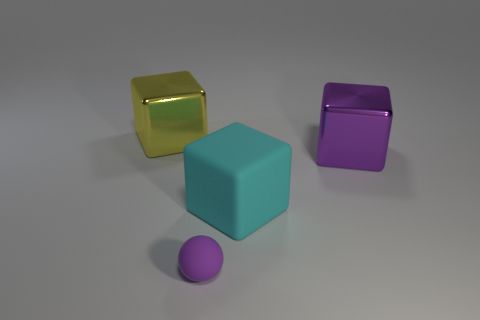The tiny matte ball has what color?
Your response must be concise. Purple. Are there more tiny purple matte things behind the large rubber thing than rubber things?
Ensure brevity in your answer.  No. There is a small purple rubber sphere; how many yellow metal cubes are in front of it?
Offer a terse response. 0. Is there a tiny object that is on the right side of the block in front of the large object that is right of the large cyan object?
Offer a terse response. No. Is the cyan cube the same size as the purple matte ball?
Keep it short and to the point. No. Are there an equal number of purple cubes left of the tiny sphere and purple blocks that are to the left of the purple cube?
Your answer should be very brief. Yes. What is the shape of the matte object behind the purple rubber sphere?
Provide a succinct answer. Cube. The purple thing that is the same size as the cyan rubber thing is what shape?
Give a very brief answer. Cube. There is a object behind the big metallic thing that is to the right of the block that is behind the large purple metal cube; what color is it?
Provide a short and direct response. Yellow. Do the cyan rubber object and the large purple metal object have the same shape?
Your answer should be very brief. Yes. 